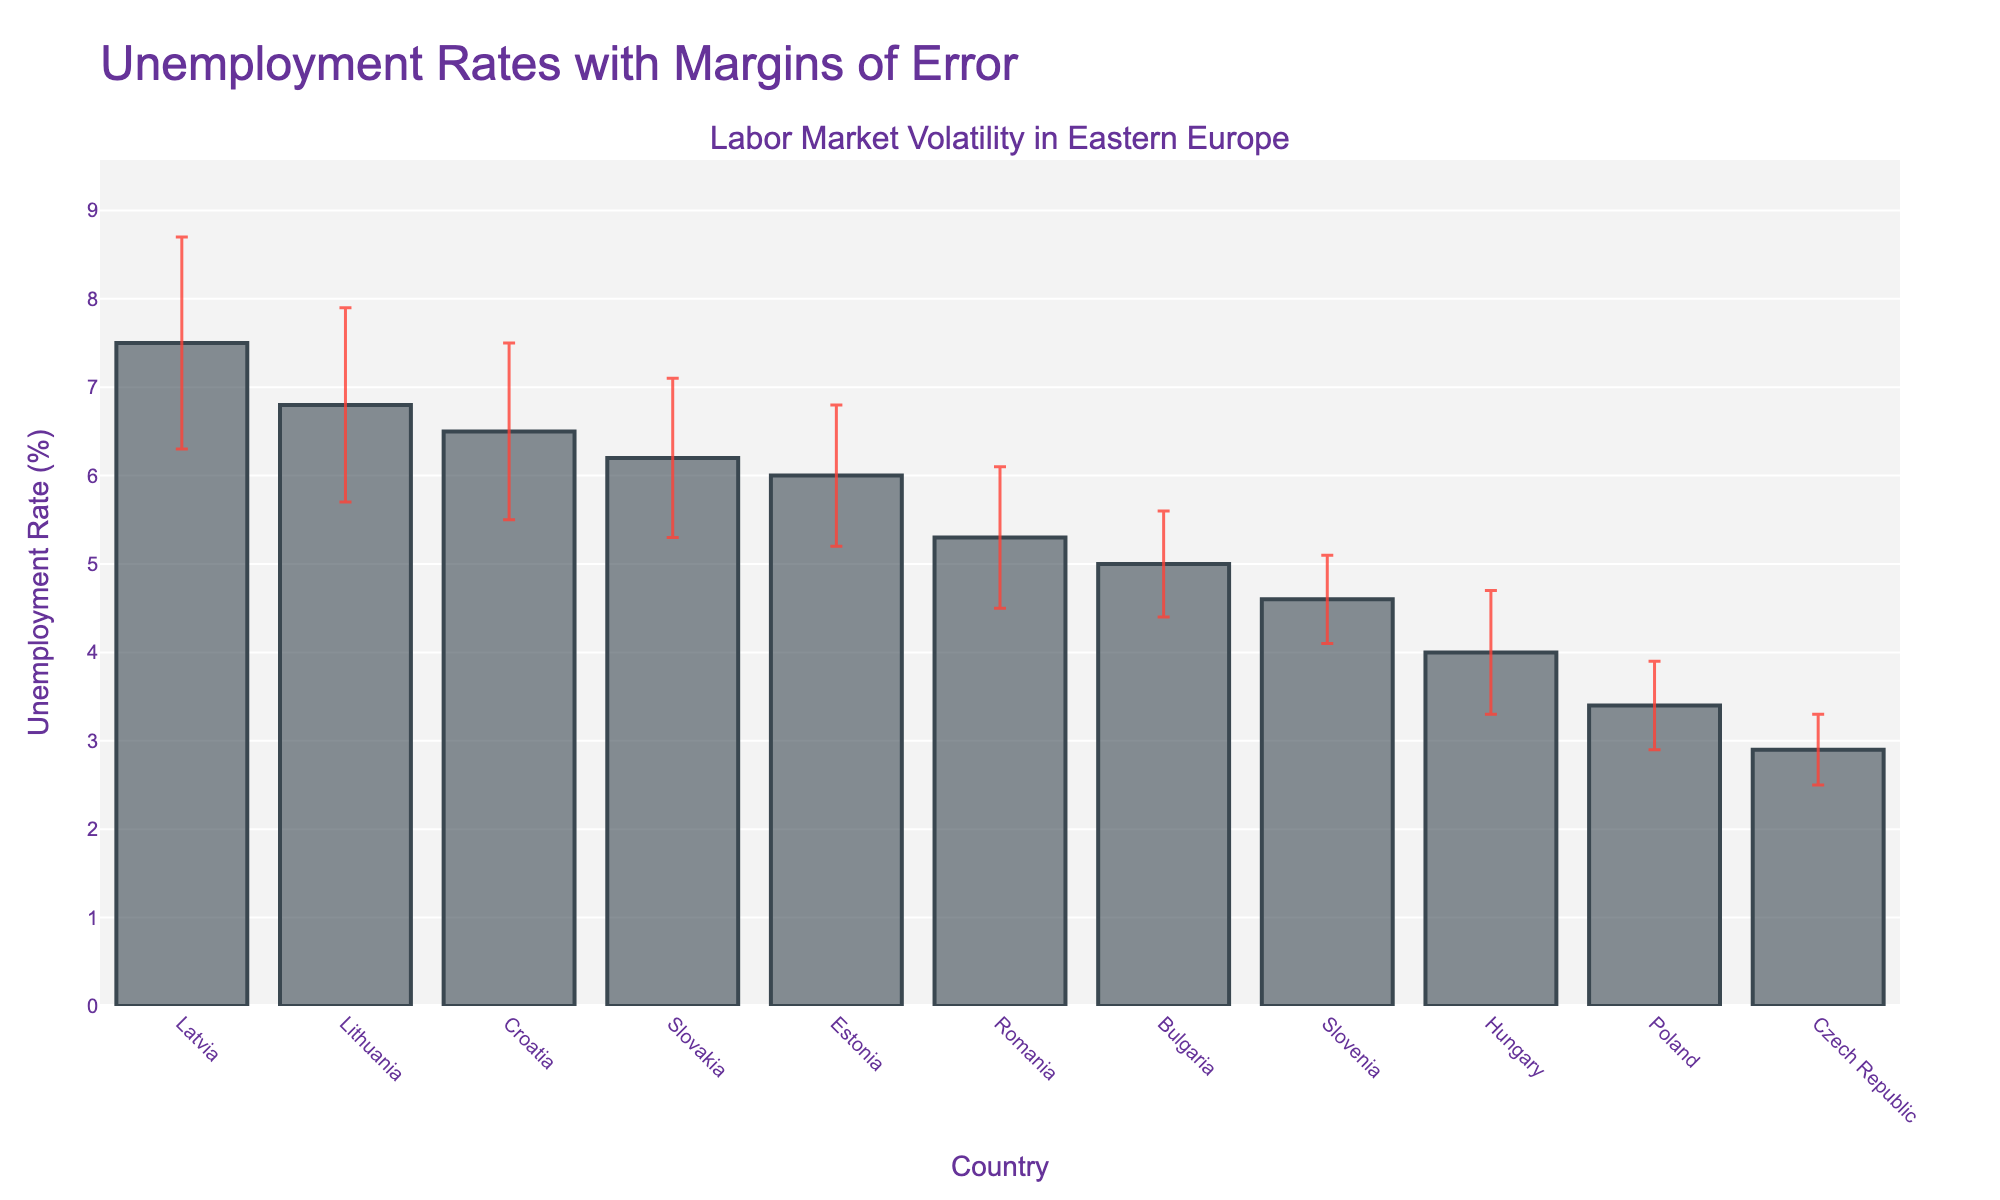What is the title of the figure? The title of the figure is located at the top, which provides an overview of what the figure is about. It states the main subject which is unemployment rates with margins of error for different countries.
Answer: Unemployment Rates with Margins of Error What country has the highest unemployment rate? We need to look at the bars in the figure and identify the one that has the highest value on the y-axis. The highest bar corresponds to Latvia.
Answer: Latvia Which two countries have the lowest unemployment rate? To find the two lowest unemployment rates, we identify the two smallest bars. The figure shows that the lowest bars are for Czech Republic and Poland.
Answer: Czech Republic and Poland What is the unemployment rate of Slovenia including its margin of error? We look at the bar for Slovenia, then add and subtract the margin of error shown as the error bar. Slovenia's unemployment rate is 4.6%, and the margin of error is 0.5%, so the rate ranges from 4.1% to 5.1%.
Answer: 4.1% to 5.1% Which country has the largest margin of error? We need to observe the length of the error bars for each country and identify the one with the longest error bar. Latvia has the largest margin of error, which is 1.2%.
Answer: Latvia How much higher is Lithuania's unemployment rate compared to Hungary's? We find the unemployment rates of Lithuania (6.8%) and Hungary (4.0%) and subtract Hungary's rate from Lithuania's rate. The difference is 6.8% - 4.0% = 2.8%.
Answer: 2.8% What is the average unemployment rate across all countries? First, sum the unemployment rates for all countries, then divide by the number of countries. The total sum is 57.2%. The number of countries is 11. The average is 57.2% / 11 = 5.2%.
Answer: 5.2% How wide is the margin of error range for Estonia? The margin of error for Estonia is 0.8%. Therefore, the range of error from the mean unemployment rate encompasses ±0.8%. This gives us a range width of 1.6%.
Answer: 1.6% Which country has a lower unemployment rate: Bulgaria or Romania? Look at the bars for Bulgaria and Romania. Bulgaria has an unemployment rate of 5.0% while Romania's is 5.3%.
Answer: Bulgaria 